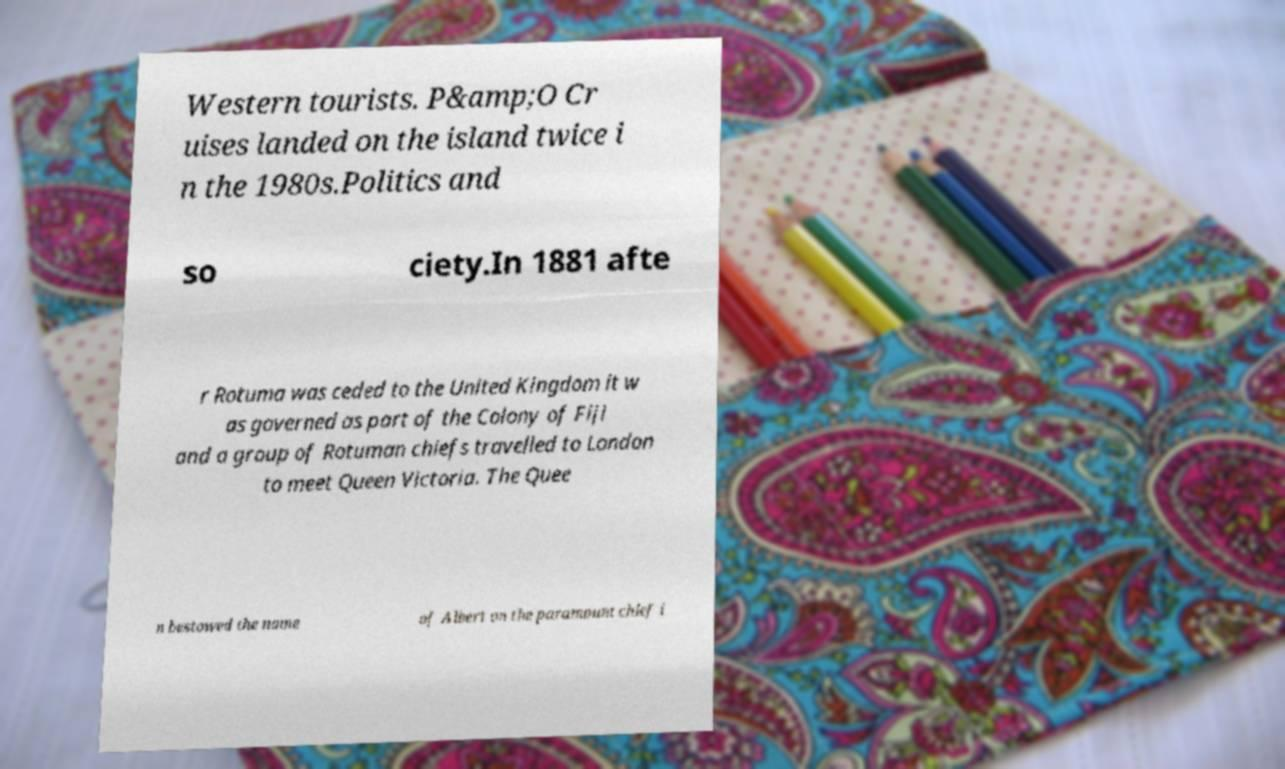Can you accurately transcribe the text from the provided image for me? Western tourists. P&amp;O Cr uises landed on the island twice i n the 1980s.Politics and so ciety.In 1881 afte r Rotuma was ceded to the United Kingdom it w as governed as part of the Colony of Fiji and a group of Rotuman chiefs travelled to London to meet Queen Victoria. The Quee n bestowed the name of Albert on the paramount chief i 